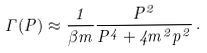<formula> <loc_0><loc_0><loc_500><loc_500>\Gamma ( P ) \approx \frac { 1 } { \beta m } \frac { P ^ { 2 } } { P ^ { 4 } + 4 m ^ { 2 } p ^ { 2 } } \, .</formula> 